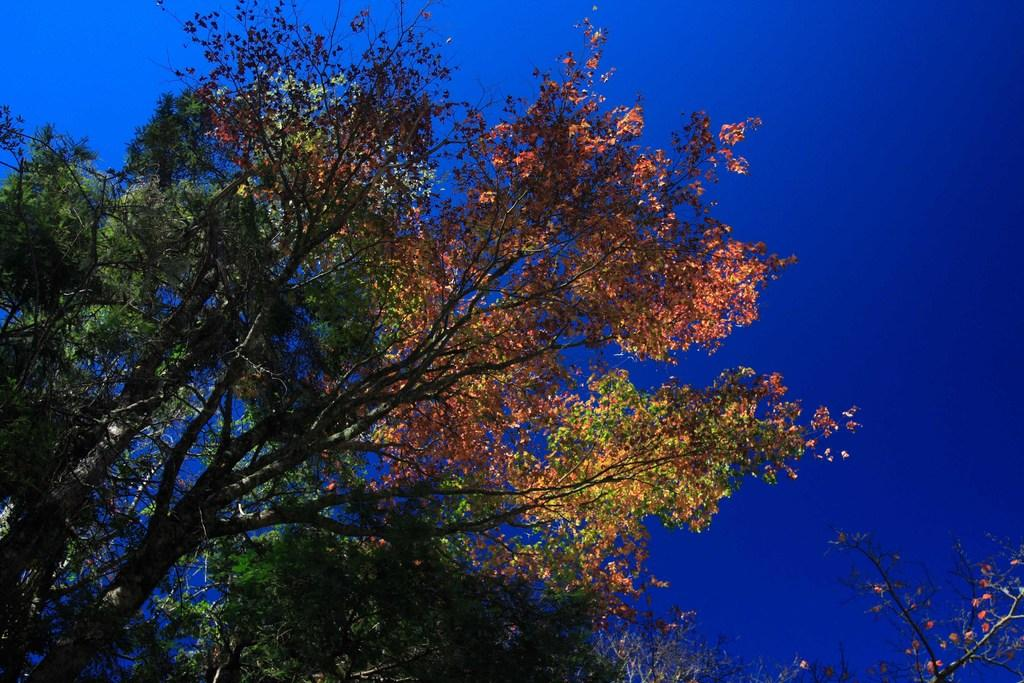What type of vegetation can be seen in the image? There are trees in the image. What part of the natural environment is visible in the image? The sky is visible in the image. Can you describe the secretary's role in the fight between the worm and the tree in the image? There is no secretary, fight, or worm present in the image. The image only features trees and the sky. 